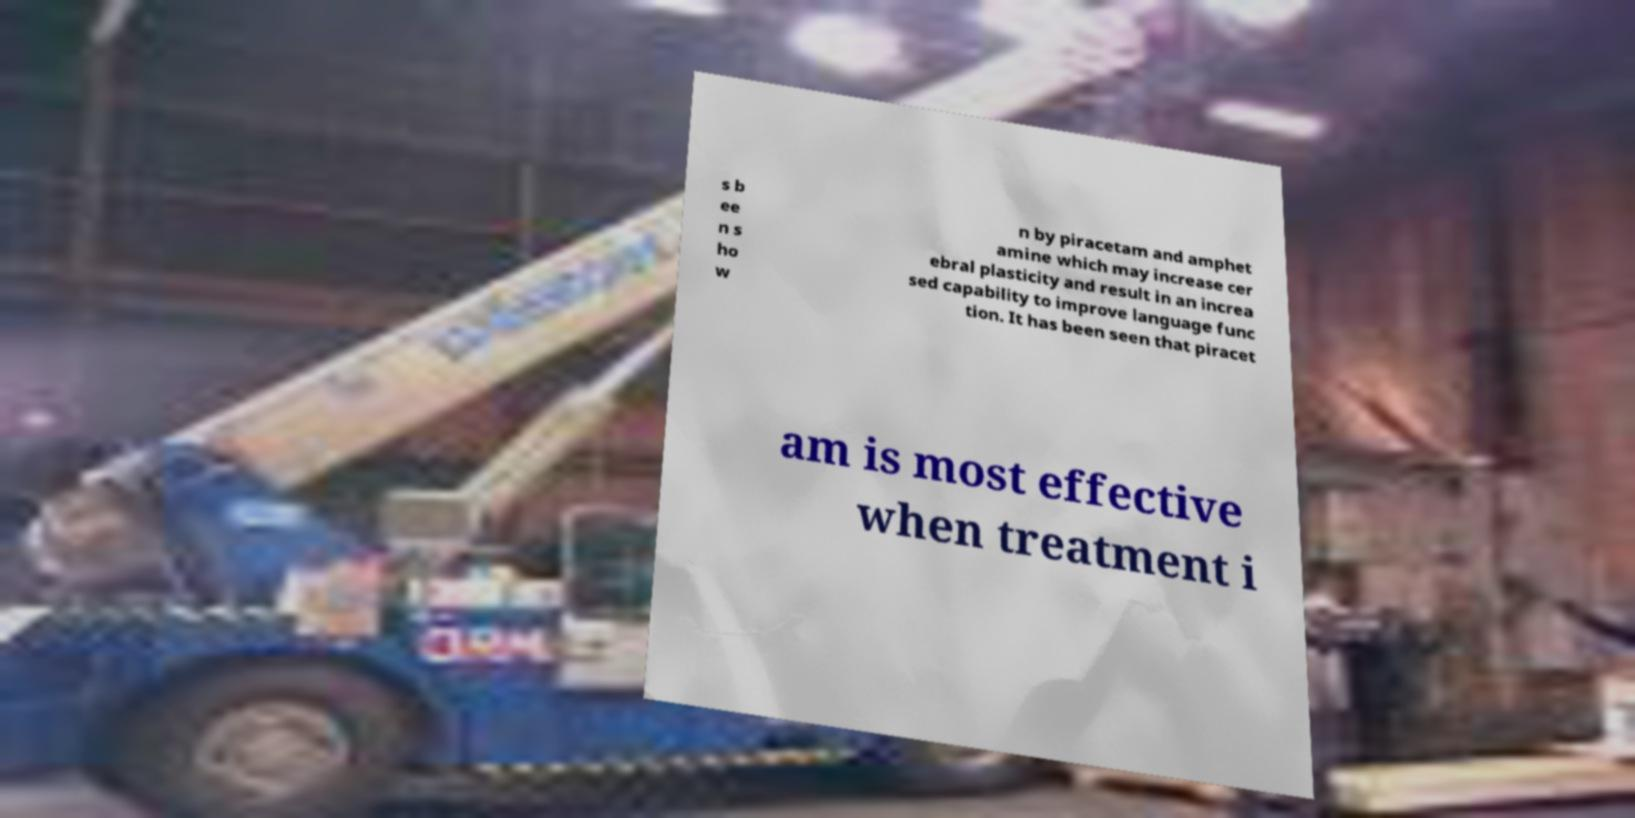There's text embedded in this image that I need extracted. Can you transcribe it verbatim? s b ee n s ho w n by piracetam and amphet amine which may increase cer ebral plasticity and result in an increa sed capability to improve language func tion. It has been seen that piracet am is most effective when treatment i 